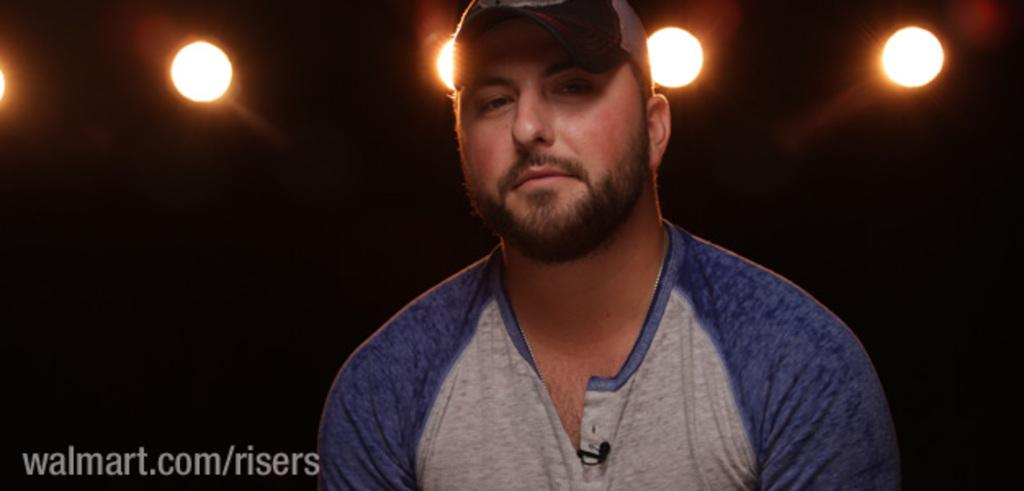What is the person in the image wearing on their head? The person in the image is wearing a cap. How would you describe the overall lighting in the image? The background of the image is dark, but there are lights visible. Can you describe the text at the bottom of the image? Unfortunately, the specific content of the text cannot be determined from the provided facts. What is the color scheme of the image? The color scheme of the image cannot be determined from the provided facts, as only the darkness of the background is mentioned. What type of circle can be seen in the image? There is no circle present in the image. What riddle is the person in the image trying to solve? There is no riddle present in the image; the person is simply wearing a cap. 